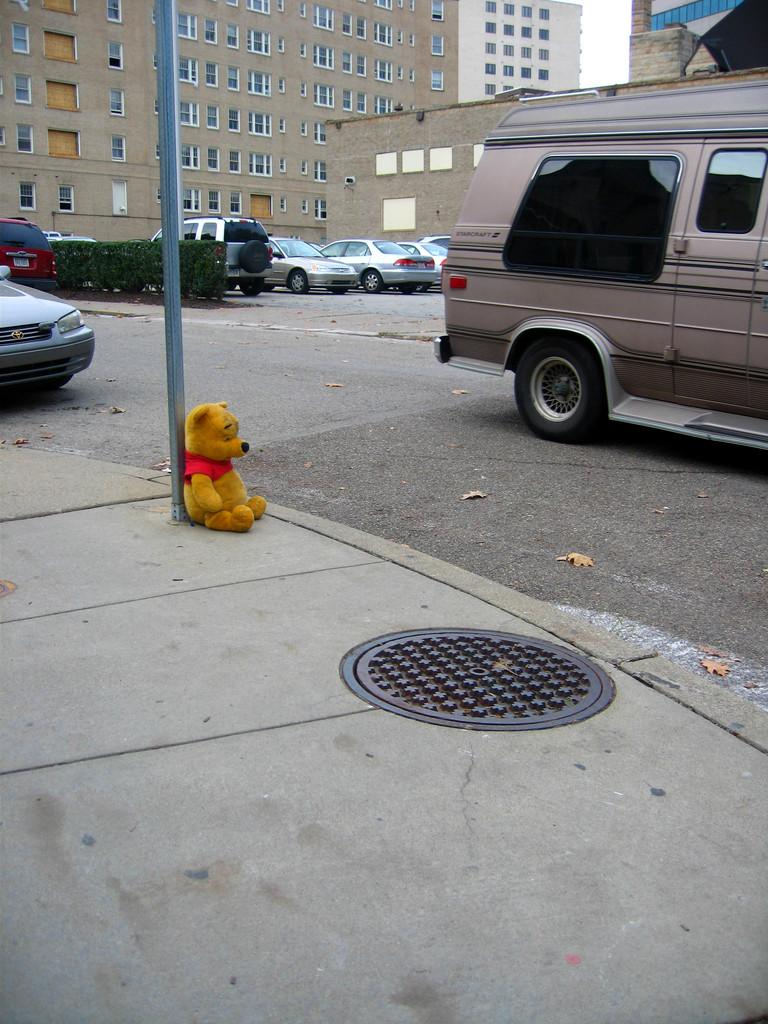What object is located on the left side of the image? There is a teddy bear on the left side of the image. What type of vehicles can be seen in the image? There are cars in the image. What structures are visible in the image? There are buildings in the image. Where are the cars and buildings located in the image? The cars and buildings are at the top side of the image. How many sisters are present in the image? There is no mention of a sister or any people in the image; it features a teddy bear, cars, and buildings. What type of division can be seen in the image? There is no division or separation of any kind mentioned in the image; it features a teddy bear, cars, and buildings. 